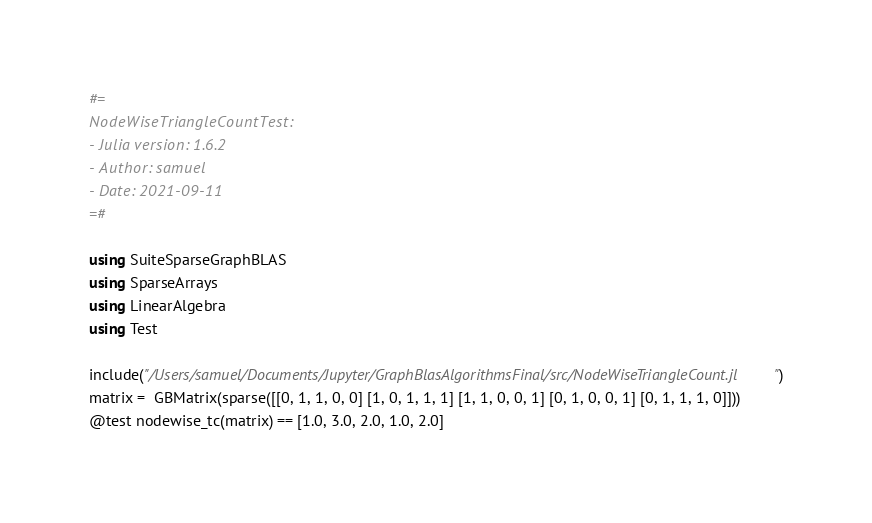<code> <loc_0><loc_0><loc_500><loc_500><_Julia_>#=
NodeWiseTriangleCountTest:
- Julia version: 1.6.2
- Author: samuel
- Date: 2021-09-11
=#

using SuiteSparseGraphBLAS
using SparseArrays
using LinearAlgebra
using Test

include("/Users/samuel/Documents/Jupyter/GraphBlasAlgorithmsFinal/src/NodeWiseTriangleCount.jl")
matrix =  GBMatrix(sparse([[0, 1, 1, 0, 0] [1, 0, 1, 1, 1] [1, 1, 0, 0, 1] [0, 1, 0, 0, 1] [0, 1, 1, 1, 0]]))
@test nodewise_tc(matrix) == [1.0, 3.0, 2.0, 1.0, 2.0]
</code> 